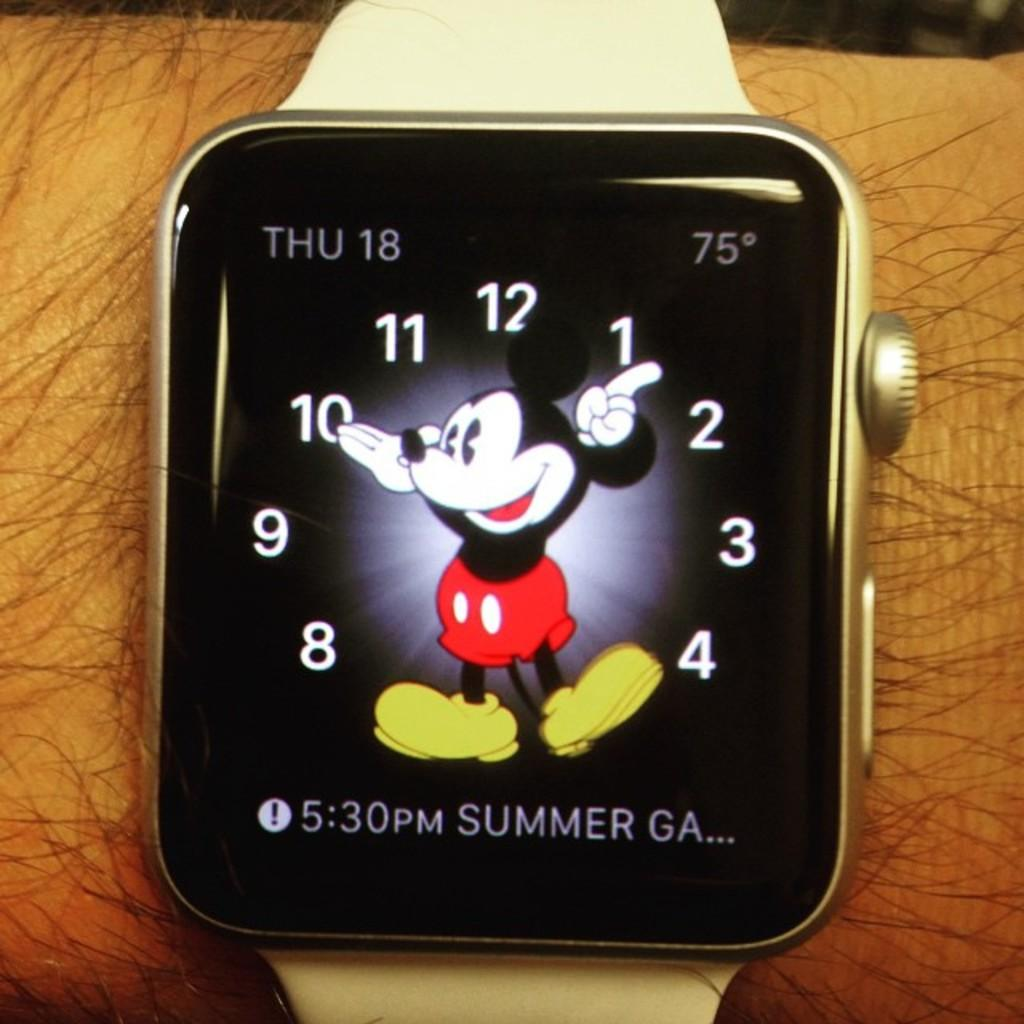Provide a one-sentence caption for the provided image. A watch with Mickey Mouse on it says that the date is Thursday 18. 